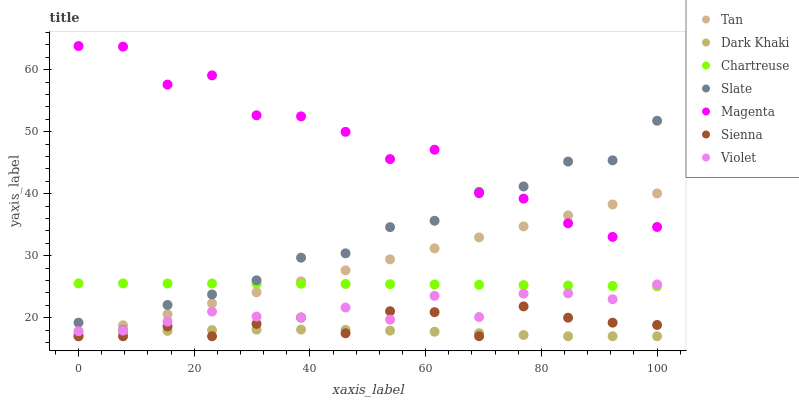Does Dark Khaki have the minimum area under the curve?
Answer yes or no. Yes. Does Magenta have the maximum area under the curve?
Answer yes or no. Yes. Does Slate have the minimum area under the curve?
Answer yes or no. No. Does Slate have the maximum area under the curve?
Answer yes or no. No. Is Tan the smoothest?
Answer yes or no. Yes. Is Magenta the roughest?
Answer yes or no. Yes. Is Slate the smoothest?
Answer yes or no. No. Is Slate the roughest?
Answer yes or no. No. Does Sienna have the lowest value?
Answer yes or no. Yes. Does Slate have the lowest value?
Answer yes or no. No. Does Magenta have the highest value?
Answer yes or no. Yes. Does Slate have the highest value?
Answer yes or no. No. Is Violet less than Slate?
Answer yes or no. Yes. Is Slate greater than Violet?
Answer yes or no. Yes. Does Magenta intersect Slate?
Answer yes or no. Yes. Is Magenta less than Slate?
Answer yes or no. No. Is Magenta greater than Slate?
Answer yes or no. No. Does Violet intersect Slate?
Answer yes or no. No. 